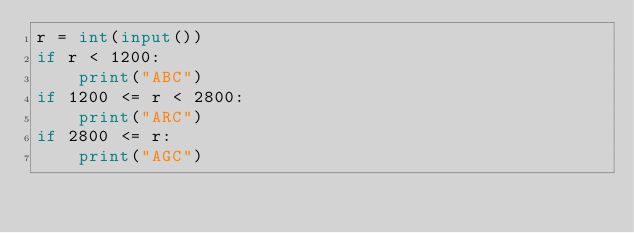<code> <loc_0><loc_0><loc_500><loc_500><_Python_>r = int(input())
if r < 1200:
    print("ABC")
if 1200 <= r < 2800:
    print("ARC")
if 2800 <= r:
    print("AGC")</code> 